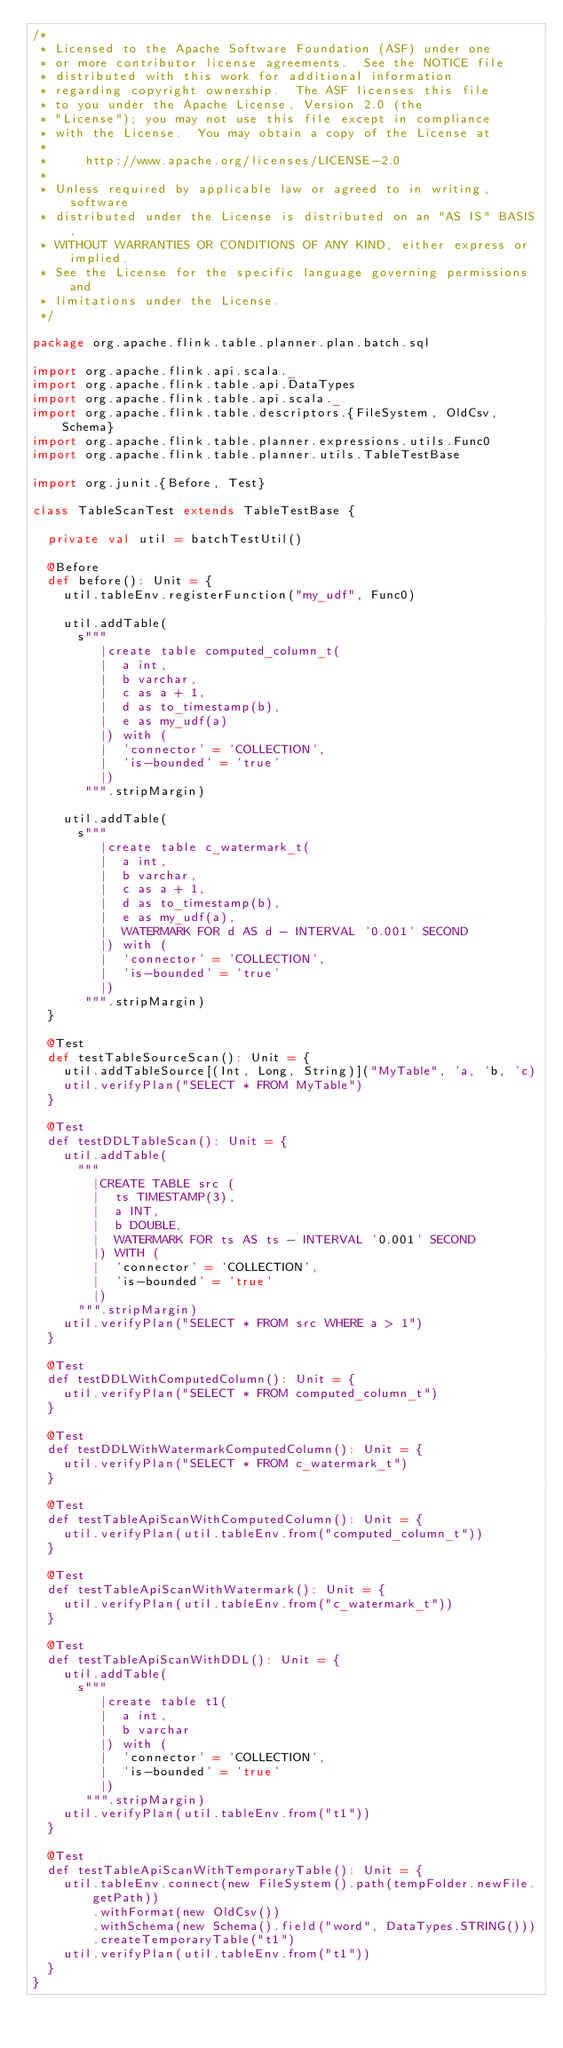Convert code to text. <code><loc_0><loc_0><loc_500><loc_500><_Scala_>/*
 * Licensed to the Apache Software Foundation (ASF) under one
 * or more contributor license agreements.  See the NOTICE file
 * distributed with this work for additional information
 * regarding copyright ownership.  The ASF licenses this file
 * to you under the Apache License, Version 2.0 (the
 * "License"); you may not use this file except in compliance
 * with the License.  You may obtain a copy of the License at
 *
 *     http://www.apache.org/licenses/LICENSE-2.0
 *
 * Unless required by applicable law or agreed to in writing, software
 * distributed under the License is distributed on an "AS IS" BASIS,
 * WITHOUT WARRANTIES OR CONDITIONS OF ANY KIND, either express or implied.
 * See the License for the specific language governing permissions and
 * limitations under the License.
 */

package org.apache.flink.table.planner.plan.batch.sql

import org.apache.flink.api.scala._
import org.apache.flink.table.api.DataTypes
import org.apache.flink.table.api.scala._
import org.apache.flink.table.descriptors.{FileSystem, OldCsv, Schema}
import org.apache.flink.table.planner.expressions.utils.Func0
import org.apache.flink.table.planner.utils.TableTestBase

import org.junit.{Before, Test}

class TableScanTest extends TableTestBase {

  private val util = batchTestUtil()

  @Before
  def before(): Unit = {
    util.tableEnv.registerFunction("my_udf", Func0)

    util.addTable(
      s"""
         |create table computed_column_t(
         |  a int,
         |  b varchar,
         |  c as a + 1,
         |  d as to_timestamp(b),
         |  e as my_udf(a)
         |) with (
         |  'connector' = 'COLLECTION',
         |  'is-bounded' = 'true'
         |)
       """.stripMargin)

    util.addTable(
      s"""
         |create table c_watermark_t(
         |  a int,
         |  b varchar,
         |  c as a + 1,
         |  d as to_timestamp(b),
         |  e as my_udf(a),
         |  WATERMARK FOR d AS d - INTERVAL '0.001' SECOND
         |) with (
         |  'connector' = 'COLLECTION',
         |  'is-bounded' = 'true'
         |)
       """.stripMargin)
  }

  @Test
  def testTableSourceScan(): Unit = {
    util.addTableSource[(Int, Long, String)]("MyTable", 'a, 'b, 'c)
    util.verifyPlan("SELECT * FROM MyTable")
  }

  @Test
  def testDDLTableScan(): Unit = {
    util.addTable(
      """
        |CREATE TABLE src (
        |  ts TIMESTAMP(3),
        |  a INT,
        |  b DOUBLE,
        |  WATERMARK FOR ts AS ts - INTERVAL '0.001' SECOND
        |) WITH (
        |  'connector' = 'COLLECTION',
        |  'is-bounded' = 'true'
        |)
      """.stripMargin)
    util.verifyPlan("SELECT * FROM src WHERE a > 1")
  }

  @Test
  def testDDLWithComputedColumn(): Unit = {
    util.verifyPlan("SELECT * FROM computed_column_t")
  }

  @Test
  def testDDLWithWatermarkComputedColumn(): Unit = {
    util.verifyPlan("SELECT * FROM c_watermark_t")
  }

  @Test
  def testTableApiScanWithComputedColumn(): Unit = {
    util.verifyPlan(util.tableEnv.from("computed_column_t"))
  }

  @Test
  def testTableApiScanWithWatermark(): Unit = {
    util.verifyPlan(util.tableEnv.from("c_watermark_t"))
  }

  @Test
  def testTableApiScanWithDDL(): Unit = {
    util.addTable(
      s"""
         |create table t1(
         |  a int,
         |  b varchar
         |) with (
         |  'connector' = 'COLLECTION',
         |  'is-bounded' = 'true'
         |)
       """.stripMargin)
    util.verifyPlan(util.tableEnv.from("t1"))
  }

  @Test
  def testTableApiScanWithTemporaryTable(): Unit = {
    util.tableEnv.connect(new FileSystem().path(tempFolder.newFile.getPath))
        .withFormat(new OldCsv())
        .withSchema(new Schema().field("word", DataTypes.STRING()))
        .createTemporaryTable("t1")
    util.verifyPlan(util.tableEnv.from("t1"))
  }
}
</code> 